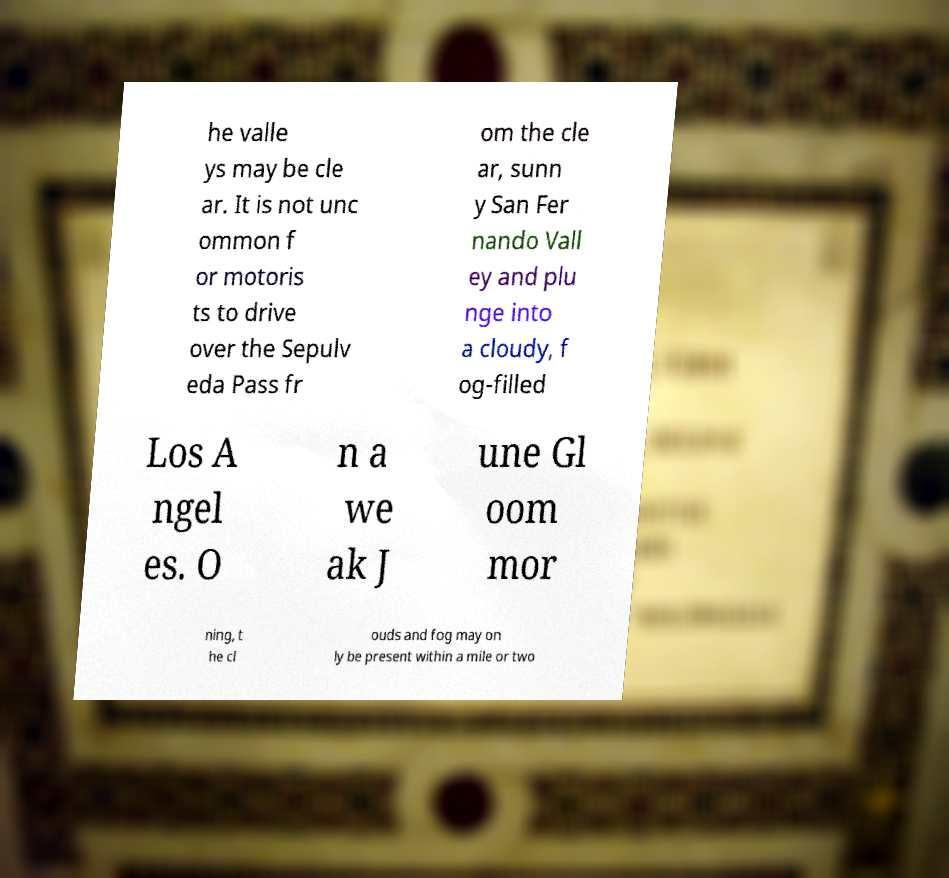Please identify and transcribe the text found in this image. he valle ys may be cle ar. It is not unc ommon f or motoris ts to drive over the Sepulv eda Pass fr om the cle ar, sunn y San Fer nando Vall ey and plu nge into a cloudy, f og-filled Los A ngel es. O n a we ak J une Gl oom mor ning, t he cl ouds and fog may on ly be present within a mile or two 